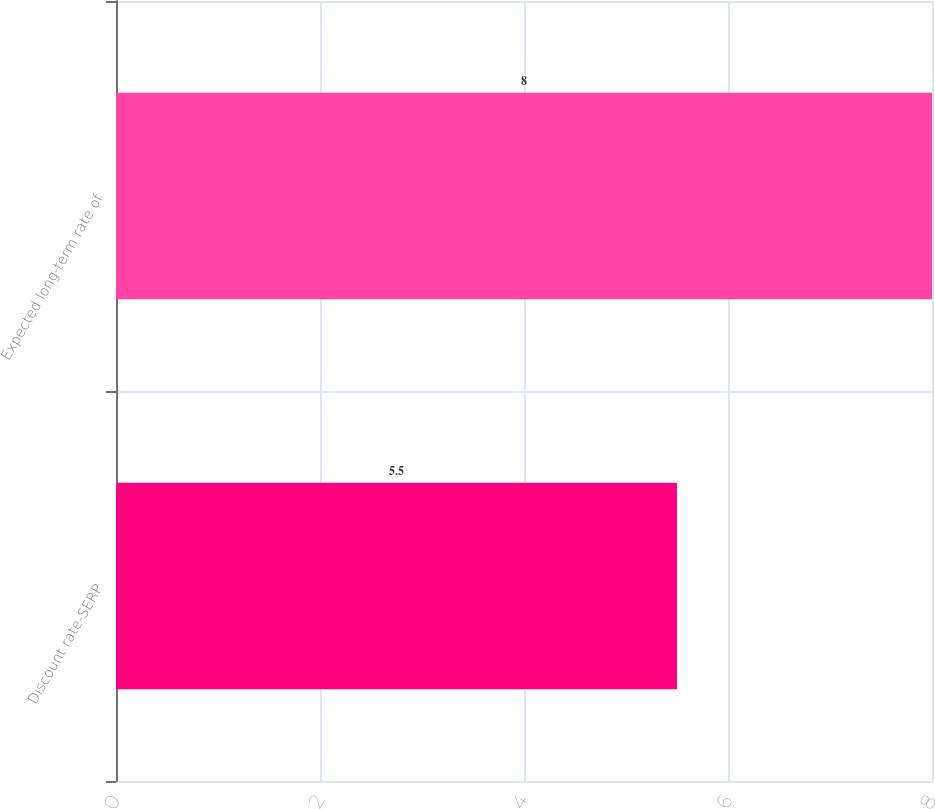Convert chart to OTSL. <chart><loc_0><loc_0><loc_500><loc_500><bar_chart><fcel>Discount rate-SERP<fcel>Expected long-term rate of<nl><fcel>5.5<fcel>8<nl></chart> 